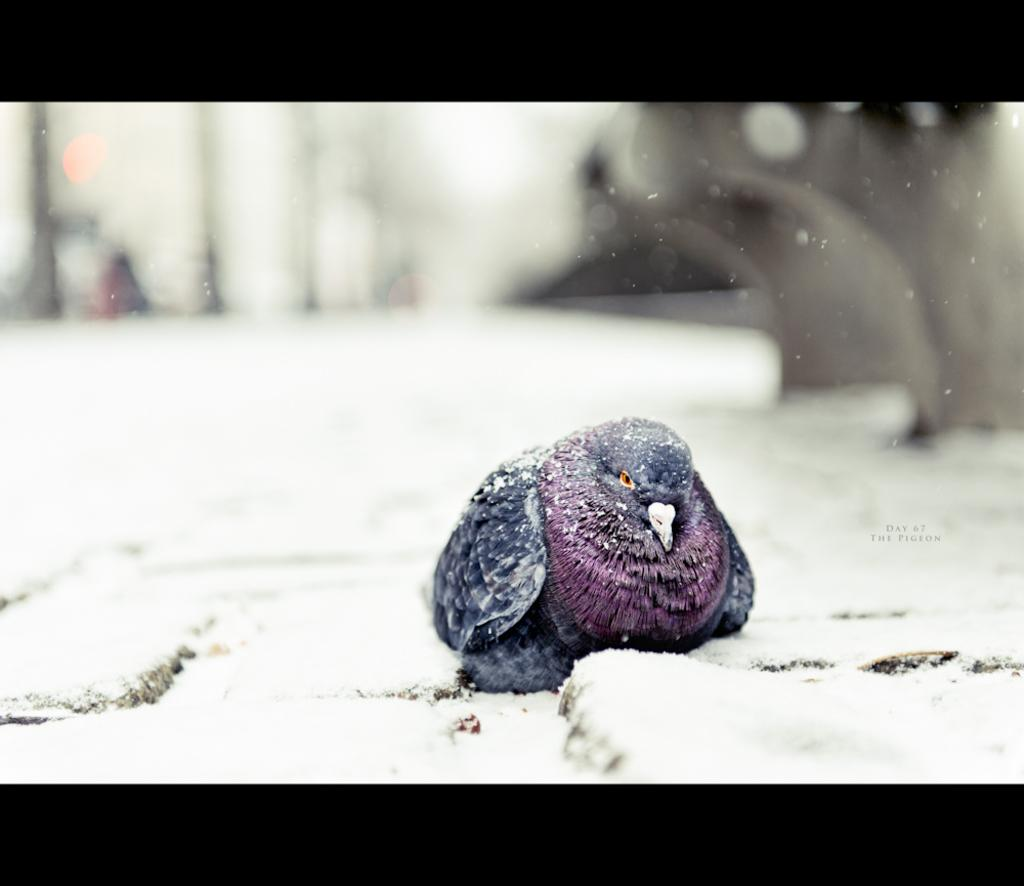What type of animal is in the image? There is a bird in the image. What is the weather condition in the image? The image depicts snow. Can you describe the background of the image? The background of the image is blurred. What type of leaf can be seen growing on the bulb in the image? There is no leaf or bulb present in the image; it features a bird in a snowy setting with a blurred background. 